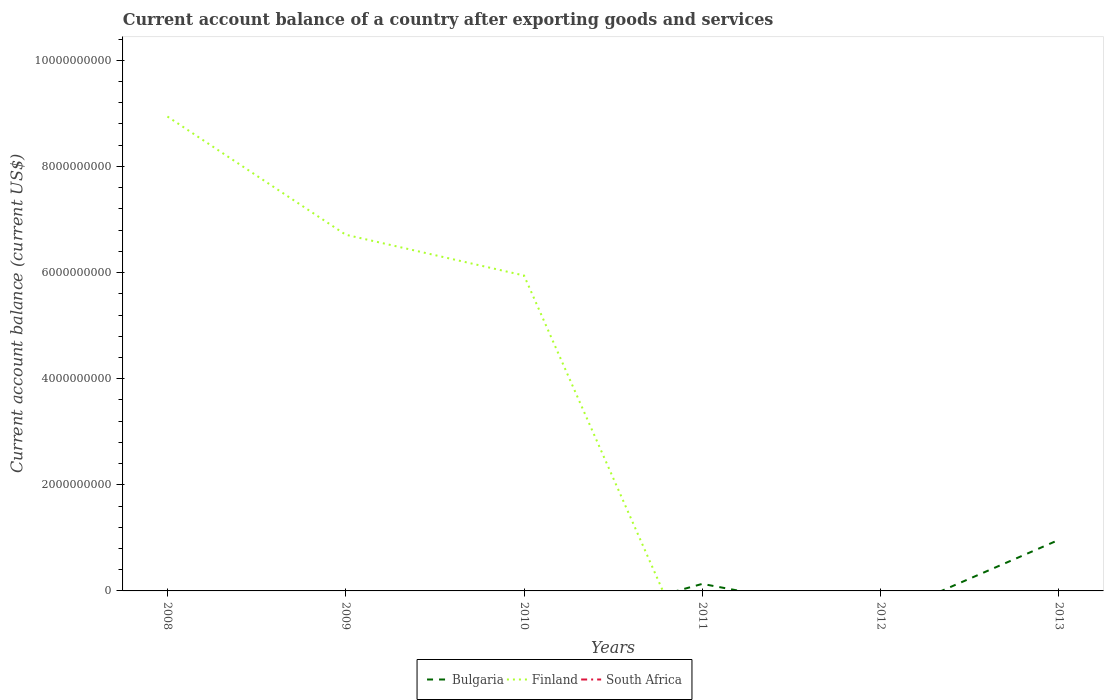How many different coloured lines are there?
Your answer should be compact. 2. Is the number of lines equal to the number of legend labels?
Give a very brief answer. No. What is the total account balance in Finland in the graph?
Your answer should be very brief. 3.00e+09. What is the difference between the highest and the second highest account balance in Bulgaria?
Keep it short and to the point. 9.63e+08. Is the account balance in South Africa strictly greater than the account balance in Bulgaria over the years?
Ensure brevity in your answer.  Yes. How many years are there in the graph?
Offer a terse response. 6. Does the graph contain grids?
Your response must be concise. No. Where does the legend appear in the graph?
Offer a terse response. Bottom center. How many legend labels are there?
Provide a succinct answer. 3. What is the title of the graph?
Keep it short and to the point. Current account balance of a country after exporting goods and services. What is the label or title of the X-axis?
Make the answer very short. Years. What is the label or title of the Y-axis?
Offer a very short reply. Current account balance (current US$). What is the Current account balance (current US$) in Bulgaria in 2008?
Ensure brevity in your answer.  0. What is the Current account balance (current US$) in Finland in 2008?
Offer a very short reply. 8.94e+09. What is the Current account balance (current US$) of Finland in 2009?
Your answer should be compact. 6.71e+09. What is the Current account balance (current US$) in Bulgaria in 2010?
Provide a succinct answer. 0. What is the Current account balance (current US$) of Finland in 2010?
Offer a terse response. 5.94e+09. What is the Current account balance (current US$) of Bulgaria in 2011?
Offer a terse response. 1.33e+08. What is the Current account balance (current US$) of South Africa in 2012?
Your response must be concise. 0. What is the Current account balance (current US$) in Bulgaria in 2013?
Your answer should be very brief. 9.63e+08. What is the Current account balance (current US$) of South Africa in 2013?
Your answer should be very brief. 0. Across all years, what is the maximum Current account balance (current US$) in Bulgaria?
Your answer should be very brief. 9.63e+08. Across all years, what is the maximum Current account balance (current US$) of Finland?
Keep it short and to the point. 8.94e+09. What is the total Current account balance (current US$) in Bulgaria in the graph?
Provide a succinct answer. 1.10e+09. What is the total Current account balance (current US$) in Finland in the graph?
Ensure brevity in your answer.  2.16e+1. What is the difference between the Current account balance (current US$) in Finland in 2008 and that in 2009?
Your response must be concise. 2.23e+09. What is the difference between the Current account balance (current US$) of Finland in 2008 and that in 2010?
Give a very brief answer. 3.00e+09. What is the difference between the Current account balance (current US$) of Finland in 2009 and that in 2010?
Keep it short and to the point. 7.69e+08. What is the difference between the Current account balance (current US$) in Bulgaria in 2011 and that in 2013?
Provide a short and direct response. -8.31e+08. What is the average Current account balance (current US$) in Bulgaria per year?
Offer a terse response. 1.83e+08. What is the average Current account balance (current US$) of Finland per year?
Your response must be concise. 3.60e+09. What is the ratio of the Current account balance (current US$) of Finland in 2008 to that in 2009?
Make the answer very short. 1.33. What is the ratio of the Current account balance (current US$) of Finland in 2008 to that in 2010?
Make the answer very short. 1.5. What is the ratio of the Current account balance (current US$) in Finland in 2009 to that in 2010?
Provide a succinct answer. 1.13. What is the ratio of the Current account balance (current US$) of Bulgaria in 2011 to that in 2013?
Offer a very short reply. 0.14. What is the difference between the highest and the second highest Current account balance (current US$) in Finland?
Keep it short and to the point. 2.23e+09. What is the difference between the highest and the lowest Current account balance (current US$) in Bulgaria?
Provide a succinct answer. 9.63e+08. What is the difference between the highest and the lowest Current account balance (current US$) in Finland?
Your answer should be compact. 8.94e+09. 